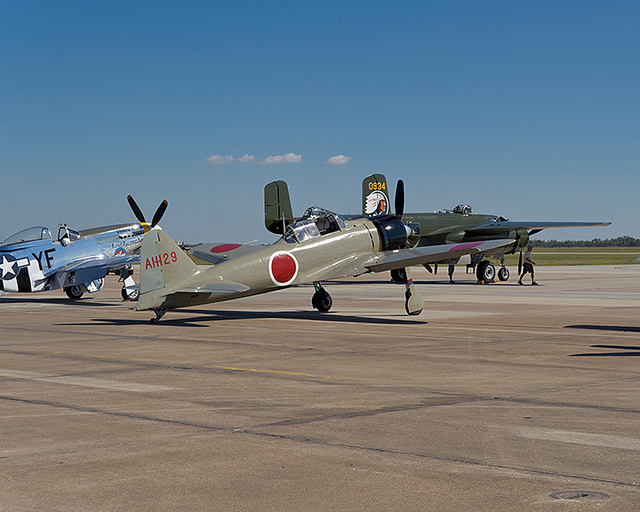Extract all visible text content from this image. A29 C334 YF 